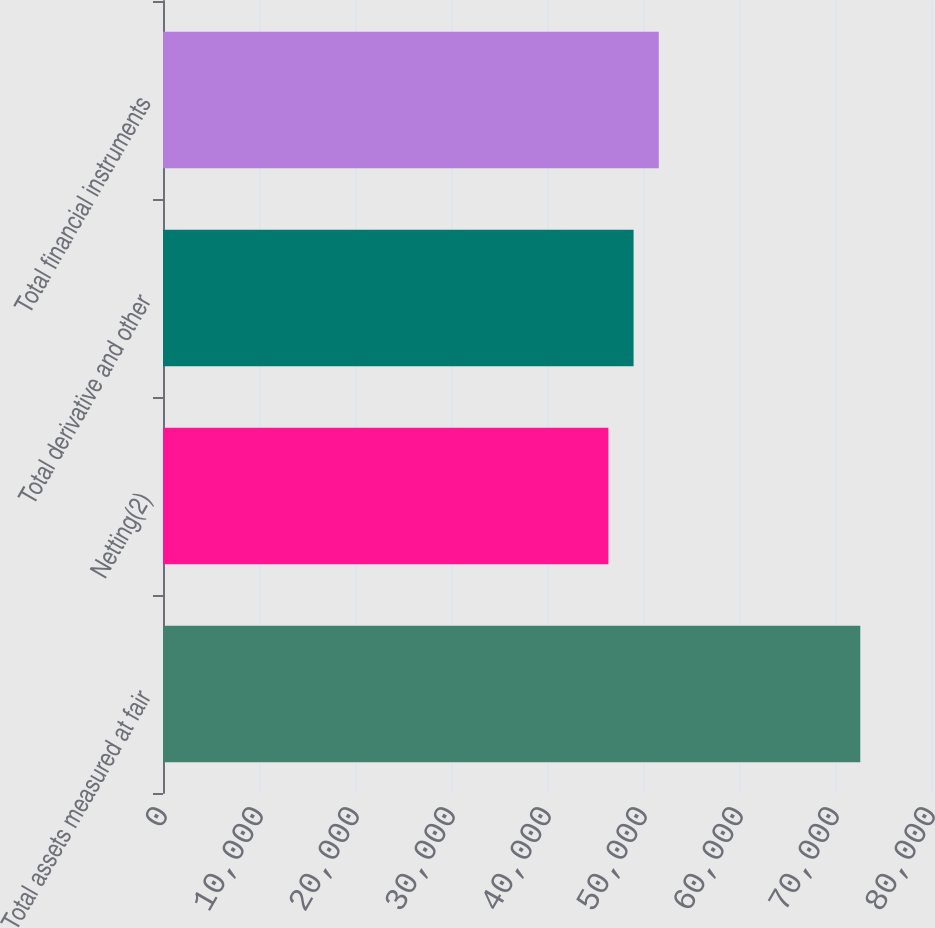Convert chart. <chart><loc_0><loc_0><loc_500><loc_500><bar_chart><fcel>Total assets measured at fair<fcel>Netting(2)<fcel>Total derivative and other<fcel>Total financial instruments<nl><fcel>72634<fcel>46395<fcel>49018.9<fcel>51642.8<nl></chart> 